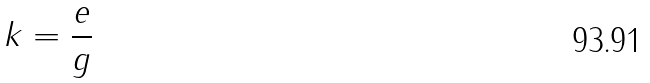<formula> <loc_0><loc_0><loc_500><loc_500>k = \frac { e } { g }</formula> 